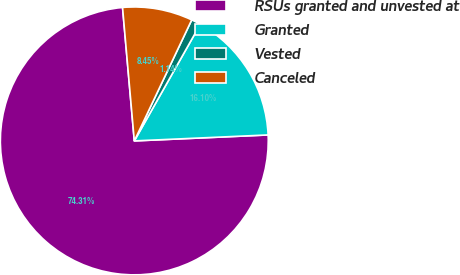<chart> <loc_0><loc_0><loc_500><loc_500><pie_chart><fcel>RSUs granted and unvested at<fcel>Granted<fcel>Vested<fcel>Canceled<nl><fcel>74.31%<fcel>16.1%<fcel>1.14%<fcel>8.45%<nl></chart> 